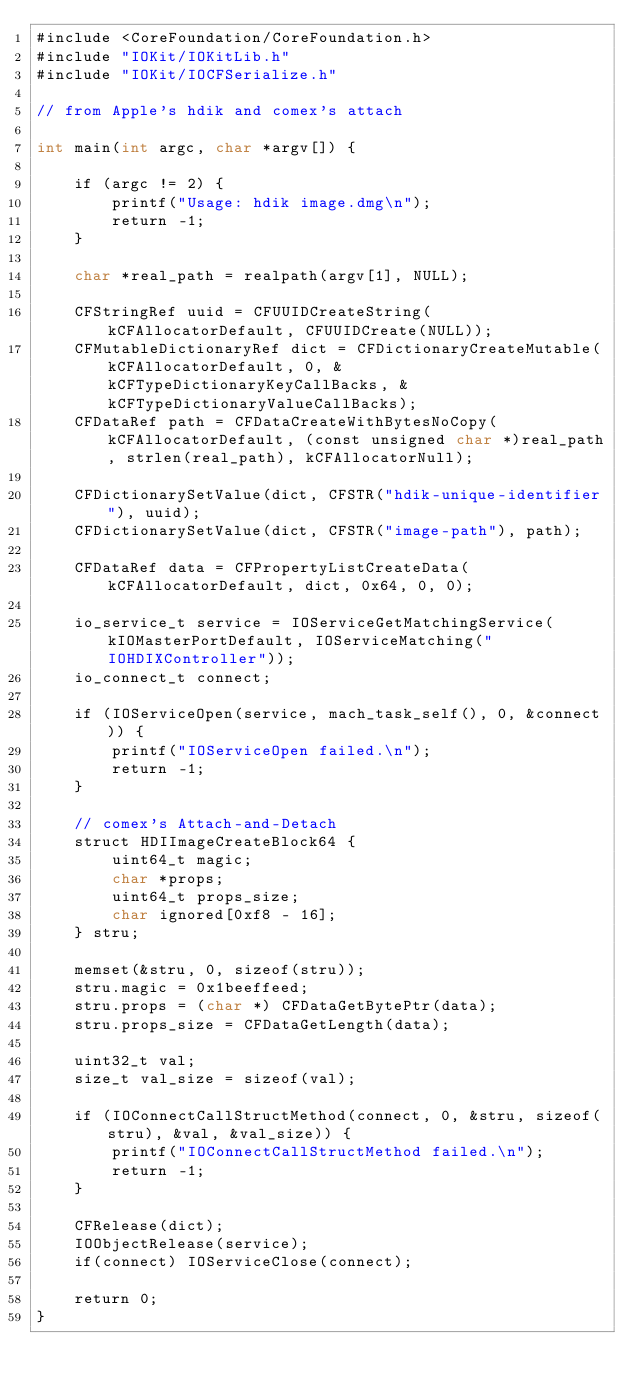Convert code to text. <code><loc_0><loc_0><loc_500><loc_500><_ObjectiveC_>#include <CoreFoundation/CoreFoundation.h>
#include "IOKit/IOKitLib.h"
#include "IOKit/IOCFSerialize.h"

// from Apple's hdik and comex's attach

int main(int argc, char *argv[]) {
	
	if (argc != 2) {
		printf("Usage: hdik image.dmg\n");
		return -1;
	}

	char *real_path = realpath(argv[1], NULL);

	CFStringRef uuid = CFUUIDCreateString(kCFAllocatorDefault, CFUUIDCreate(NULL));
    CFMutableDictionaryRef dict = CFDictionaryCreateMutable(kCFAllocatorDefault, 0, &kCFTypeDictionaryKeyCallBacks, &kCFTypeDictionaryValueCallBacks);
	CFDataRef path = CFDataCreateWithBytesNoCopy(kCFAllocatorDefault, (const unsigned char *)real_path, strlen(real_path), kCFAllocatorNull);

	CFDictionarySetValue(dict, CFSTR("hdik-unique-identifier"), uuid);
	CFDictionarySetValue(dict, CFSTR("image-path"), path);

	CFDataRef data = CFPropertyListCreateData(kCFAllocatorDefault, dict, 0x64, 0, 0);

	io_service_t service = IOServiceGetMatchingService(kIOMasterPortDefault, IOServiceMatching("IOHDIXController"));
    io_connect_t connect;

	if (IOServiceOpen(service, mach_task_self(), 0, &connect)) {
		printf("IOServiceOpen failed.\n");
		return -1;
	}

	// comex's Attach-and-Detach
	struct HDIImageCreateBlock64 {
        uint64_t magic;
        char *props;
        uint64_t props_size;
        char ignored[0xf8 - 16];
    } stru;
	
    memset(&stru, 0, sizeof(stru));
    stru.magic = 0x1beeffeed;
    stru.props = (char *) CFDataGetBytePtr(data);
    stru.props_size = CFDataGetLength(data);

    uint32_t val;
    size_t val_size = sizeof(val);

	if (IOConnectCallStructMethod(connect, 0, &stru, sizeof(stru), &val, &val_size)) {
		printf("IOConnectCallStructMethod failed.\n");
		return -1;
	}

	CFRelease(dict);
	IOObjectRelease(service);
	if(connect) IOServiceClose(connect);

	return 0;
}
</code> 